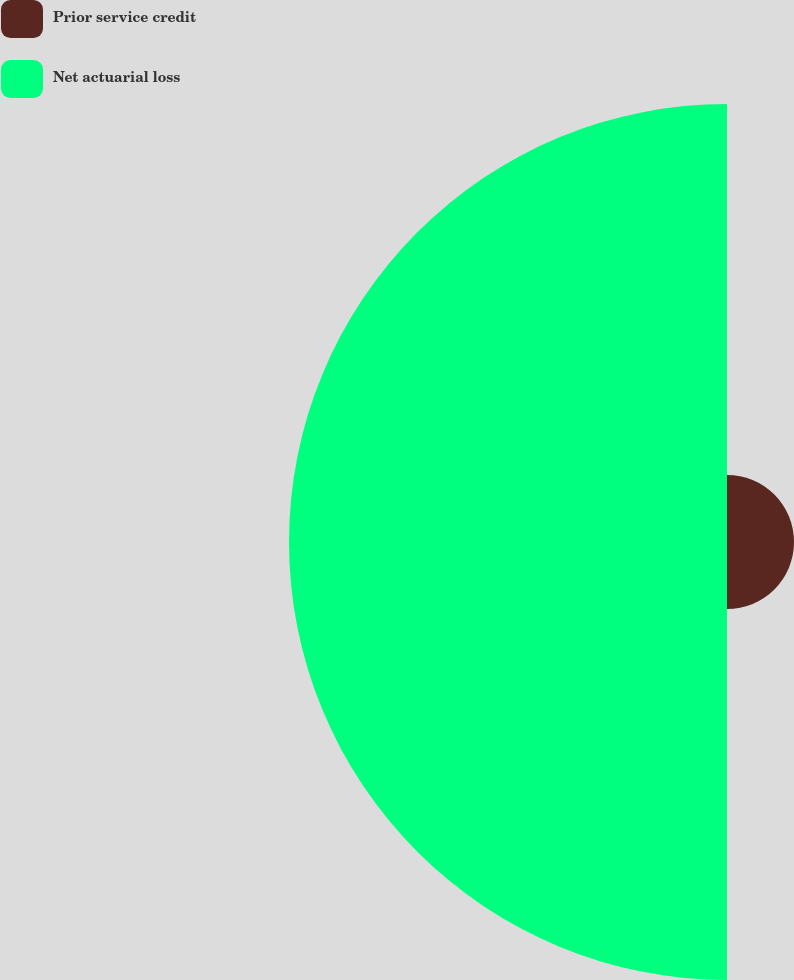<chart> <loc_0><loc_0><loc_500><loc_500><pie_chart><fcel>Prior service credit<fcel>Net actuarial loss<nl><fcel>13.27%<fcel>86.73%<nl></chart> 